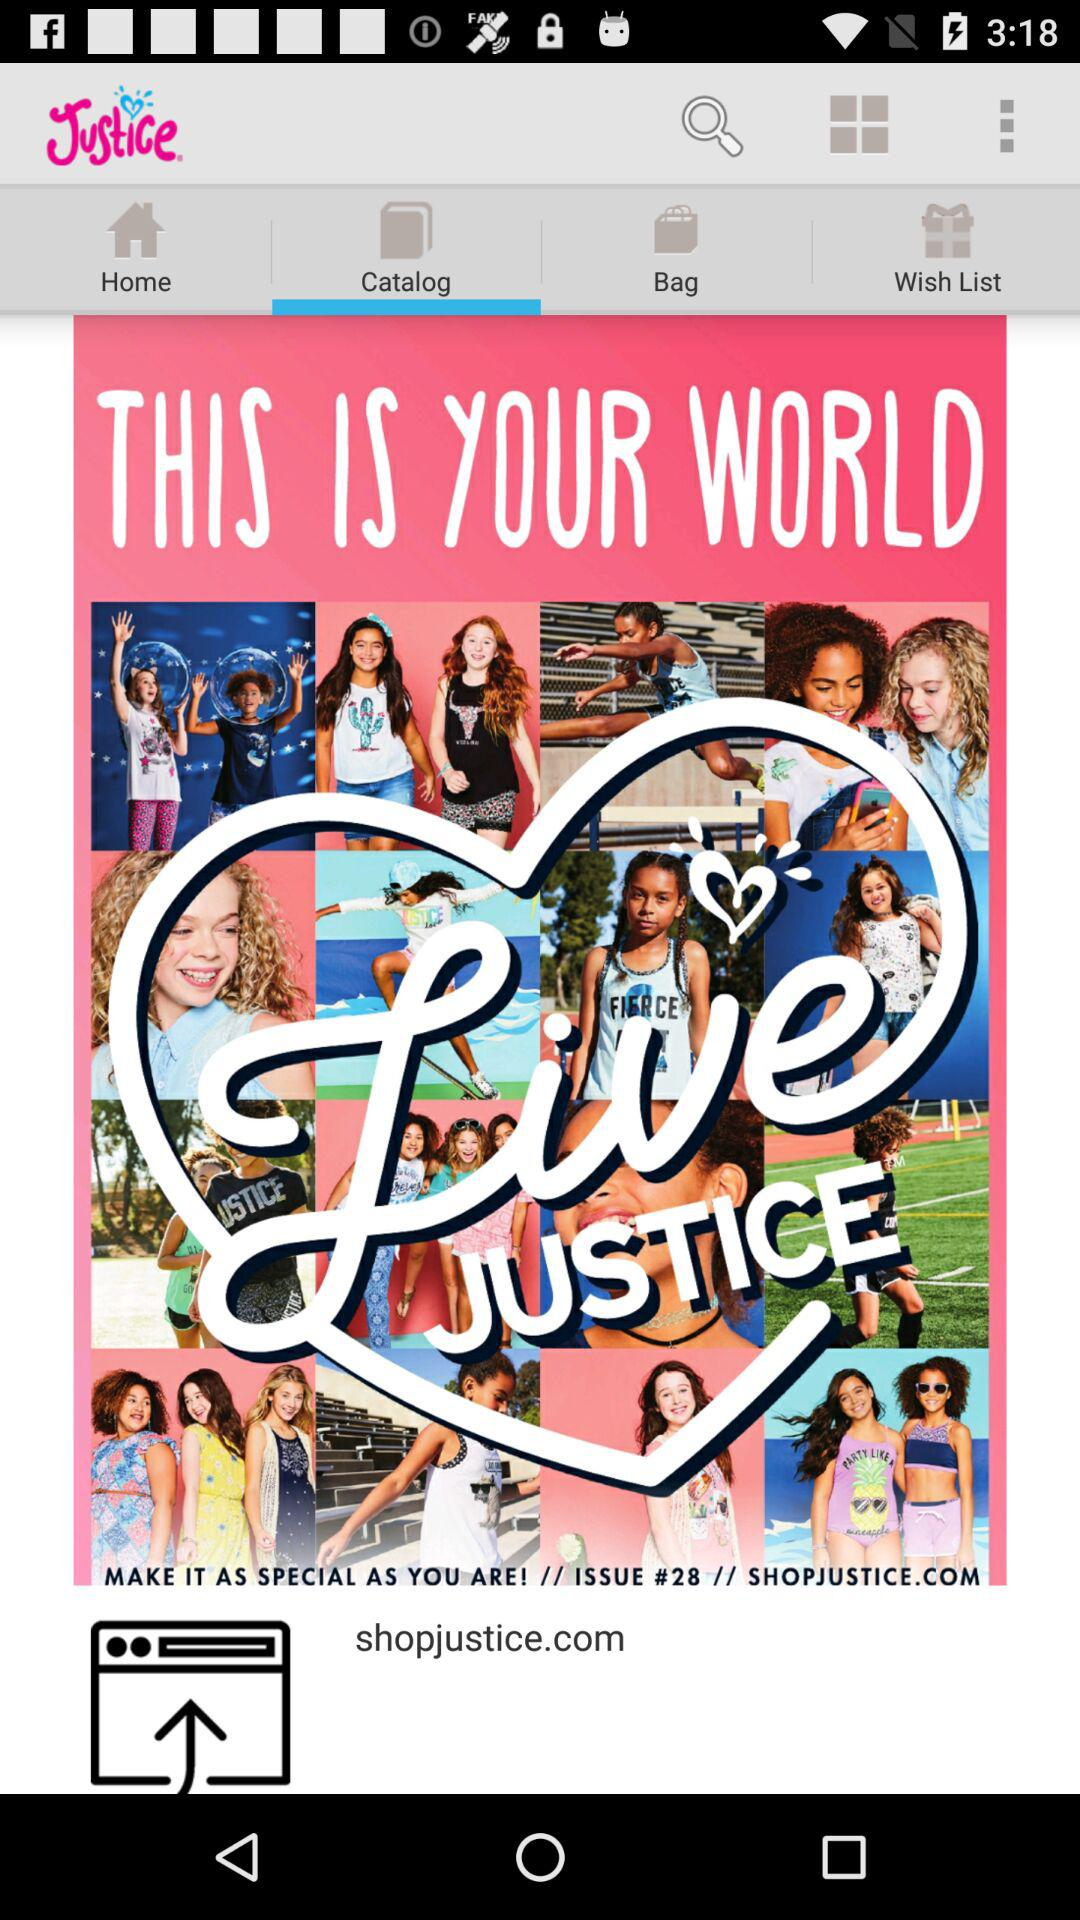What is the website name? The website name is shopjustice.com. 